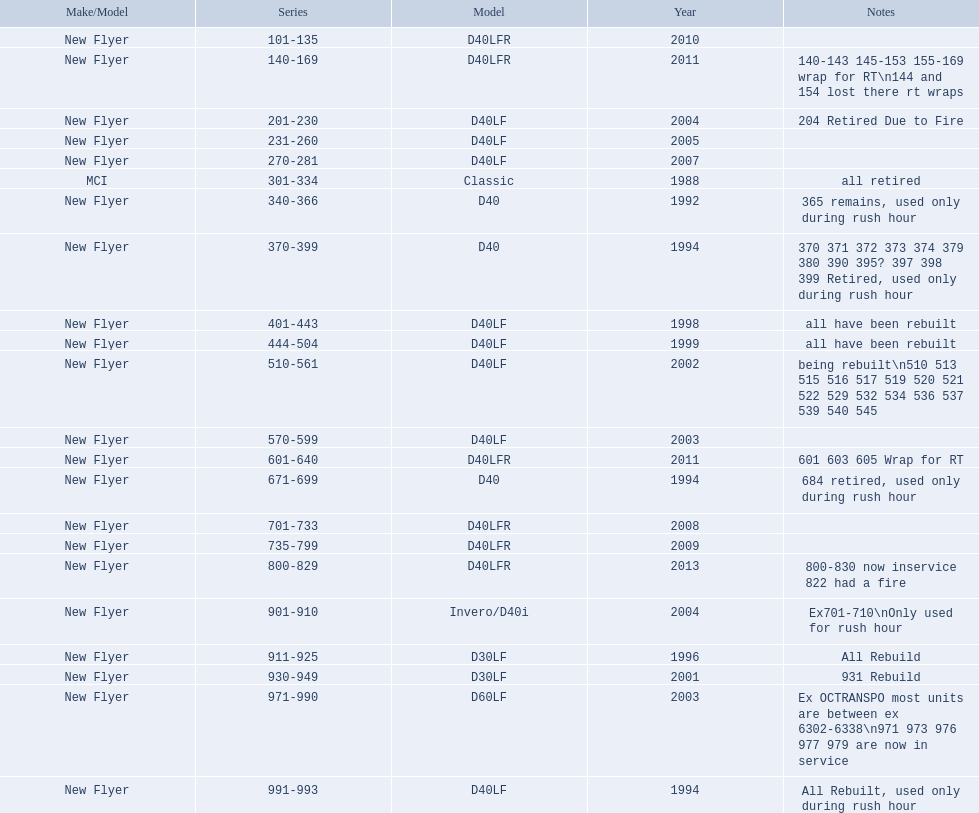What are the entire range of bus series? 101-135, 140-169, 201-230, 231-260, 270-281, 301-334, 340-366, 370-399, 401-443, 444-504, 510-561, 570-599, 601-640, 671-699, 701-733, 735-799, 800-829, 901-910, 911-925, 930-949, 971-990, 991-993. Which ones are the most recent? 800-829. 